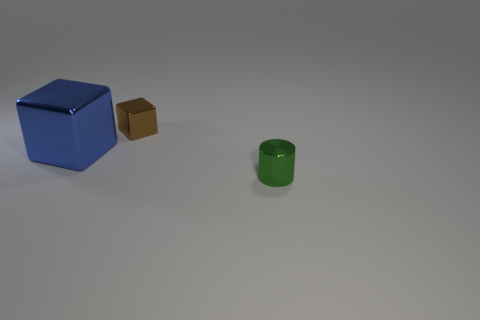Subtract 2 blocks. How many blocks are left? 0 Add 2 large spheres. How many objects exist? 5 Subtract all blue blocks. How many blocks are left? 1 Subtract all blocks. How many objects are left? 1 Add 1 spheres. How many spheres exist? 1 Subtract 0 green spheres. How many objects are left? 3 Subtract all blue blocks. Subtract all red cylinders. How many blocks are left? 1 Subtract all brown blocks. How many red cylinders are left? 0 Subtract all red matte spheres. Subtract all blocks. How many objects are left? 1 Add 2 small brown cubes. How many small brown cubes are left? 3 